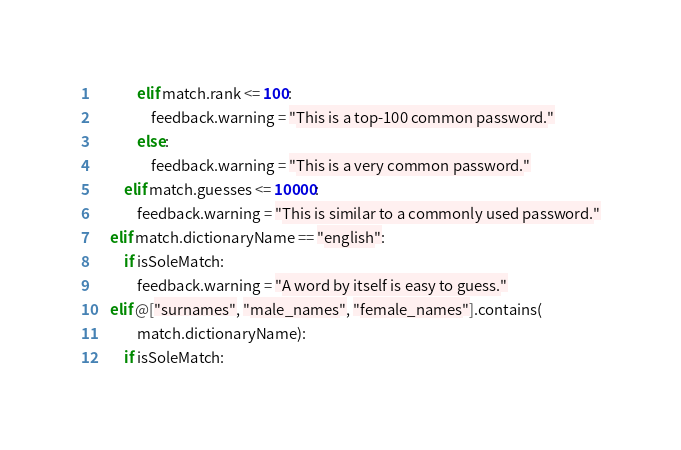Convert code to text. <code><loc_0><loc_0><loc_500><loc_500><_Nim_>            elif match.rank <= 100:
                feedback.warning = "This is a top-100 common password."
            else:
                feedback.warning = "This is a very common password."
        elif match.guesses <= 10000:
            feedback.warning = "This is similar to a commonly used password."
    elif match.dictionaryName == "english":
        if isSoleMatch:
            feedback.warning = "A word by itself is easy to guess."
    elif @["surnames", "male_names", "female_names"].contains(
            match.dictionaryName):
        if isSoleMatch:</code> 